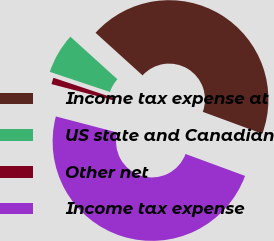Convert chart. <chart><loc_0><loc_0><loc_500><loc_500><pie_chart><fcel>Income tax expense at<fcel>US state and Canadian<fcel>Other net<fcel>Income tax expense<nl><fcel>43.9%<fcel>6.58%<fcel>1.06%<fcel>48.46%<nl></chart> 